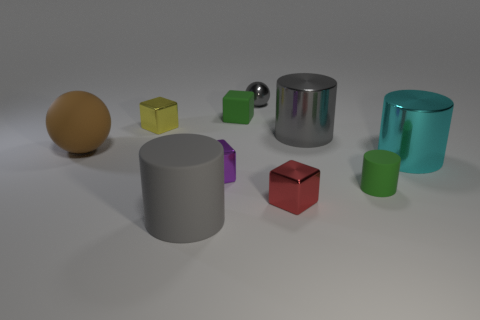Is the number of large cyan shiny cylinders that are in front of the tiny green matte cube less than the number of large matte objects?
Provide a short and direct response. Yes. How many tiny purple metallic things are there?
Your answer should be very brief. 1. What number of metallic spheres are the same color as the tiny cylinder?
Your response must be concise. 0. Is the yellow object the same shape as the purple object?
Offer a very short reply. Yes. What is the size of the green thing on the left side of the tiny green object that is in front of the brown ball?
Ensure brevity in your answer.  Small. Are there any yellow things that have the same size as the cyan cylinder?
Keep it short and to the point. No. There is a ball that is in front of the small yellow shiny cube; is its size the same as the shiny cylinder that is in front of the big rubber sphere?
Offer a terse response. Yes. What is the shape of the green matte object that is to the left of the metallic object behind the small yellow cube?
Your answer should be compact. Cube. What number of shiny objects are in front of the purple cube?
Offer a terse response. 1. What color is the small sphere that is made of the same material as the tiny yellow cube?
Provide a short and direct response. Gray. 